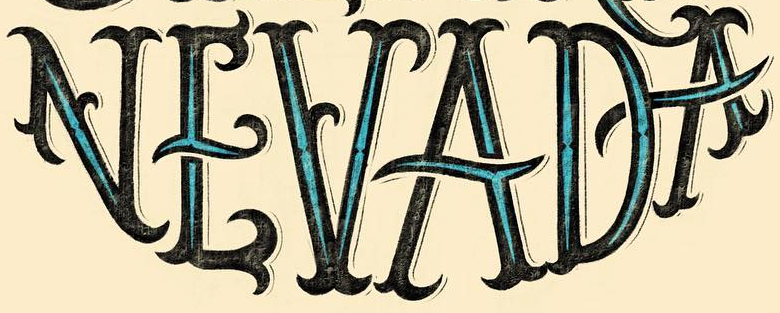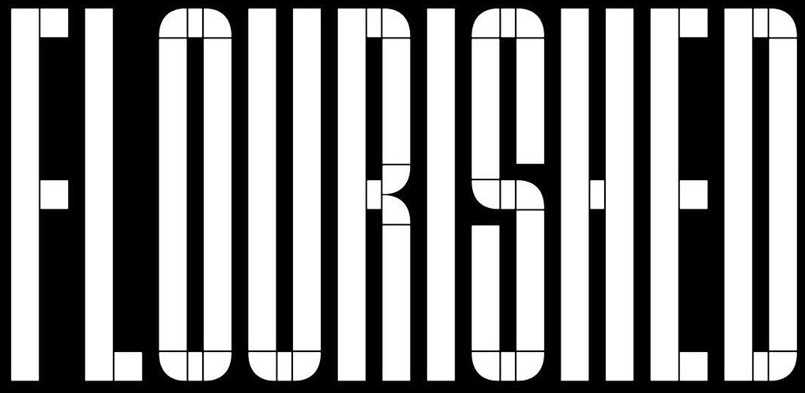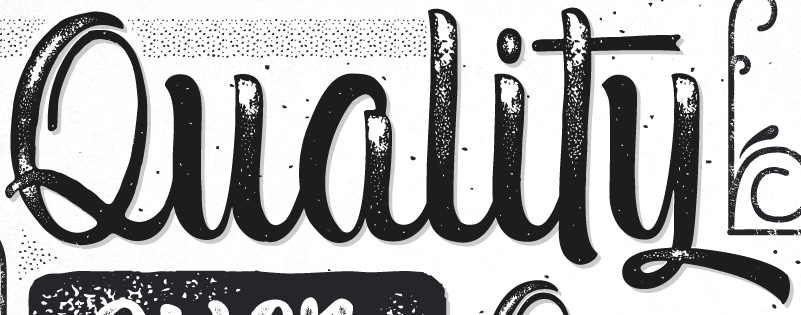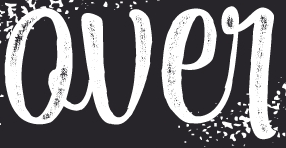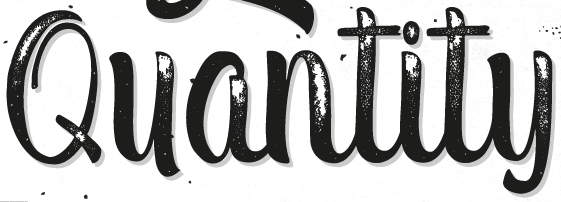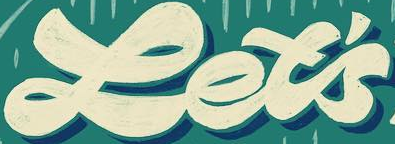What text is displayed in these images sequentially, separated by a semicolon? NEVADA; FLOURISHED; Quality; Qver; Quantity; Let's 